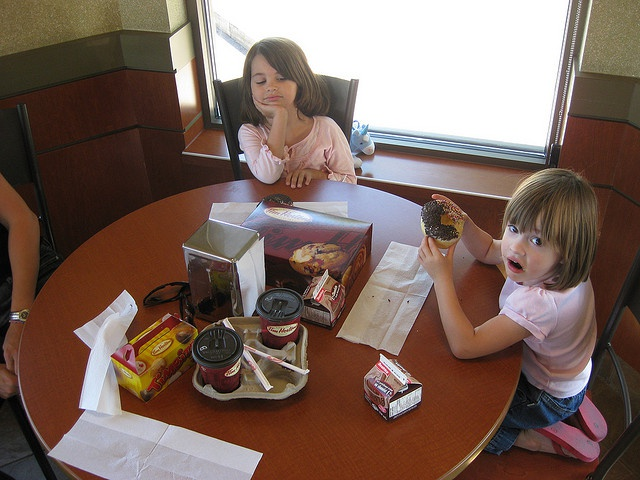Describe the objects in this image and their specific colors. I can see dining table in olive, maroon, darkgray, black, and gray tones, people in olive, gray, black, and maroon tones, people in olive, gray, and darkgray tones, chair in olive, black, maroon, gray, and navy tones, and people in olive, maroon, black, and brown tones in this image. 